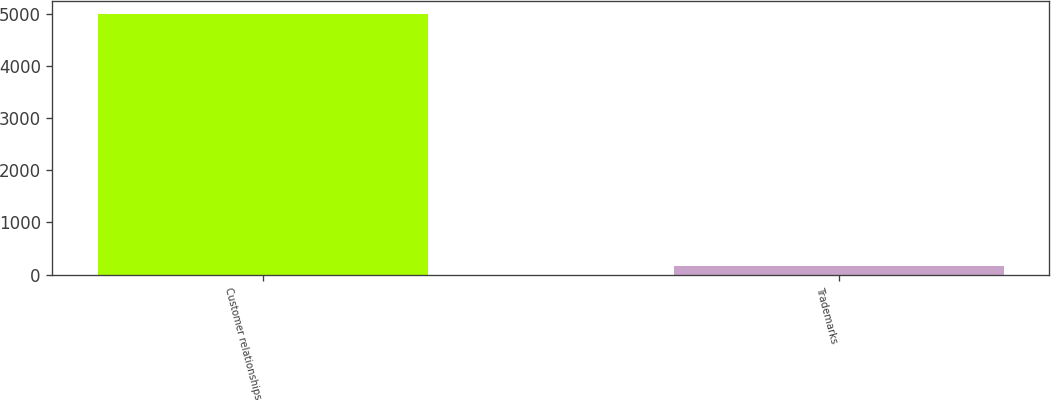Convert chart to OTSL. <chart><loc_0><loc_0><loc_500><loc_500><bar_chart><fcel>Customer relationships<fcel>Trademarks<nl><fcel>5000<fcel>159<nl></chart> 